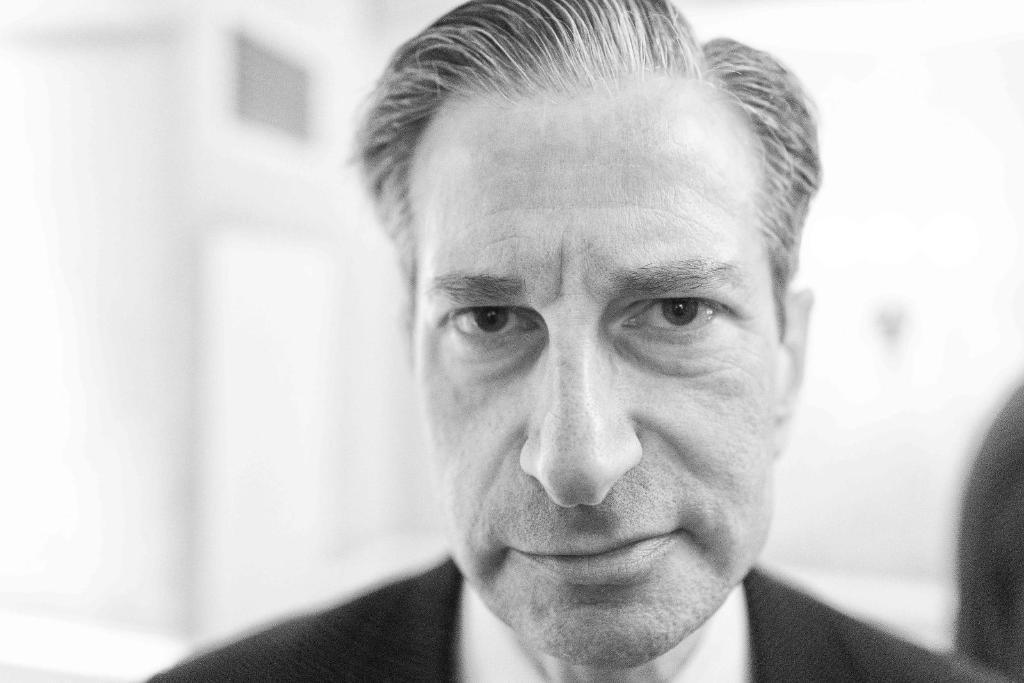In one or two sentences, can you explain what this image depicts? In the foreground of this black and white image, there is a man wearing suit and the background image is blurred. 